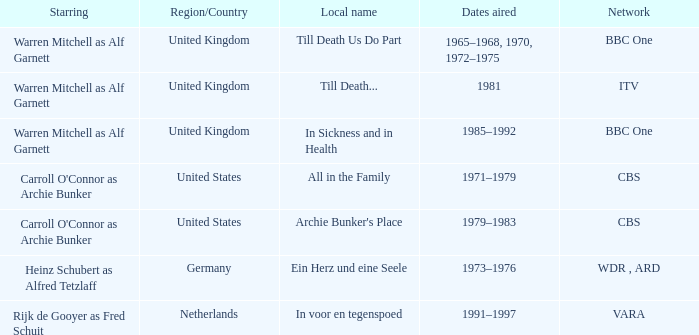Who was the star for the Vara network? Rijk de Gooyer as Fred Schuit. 